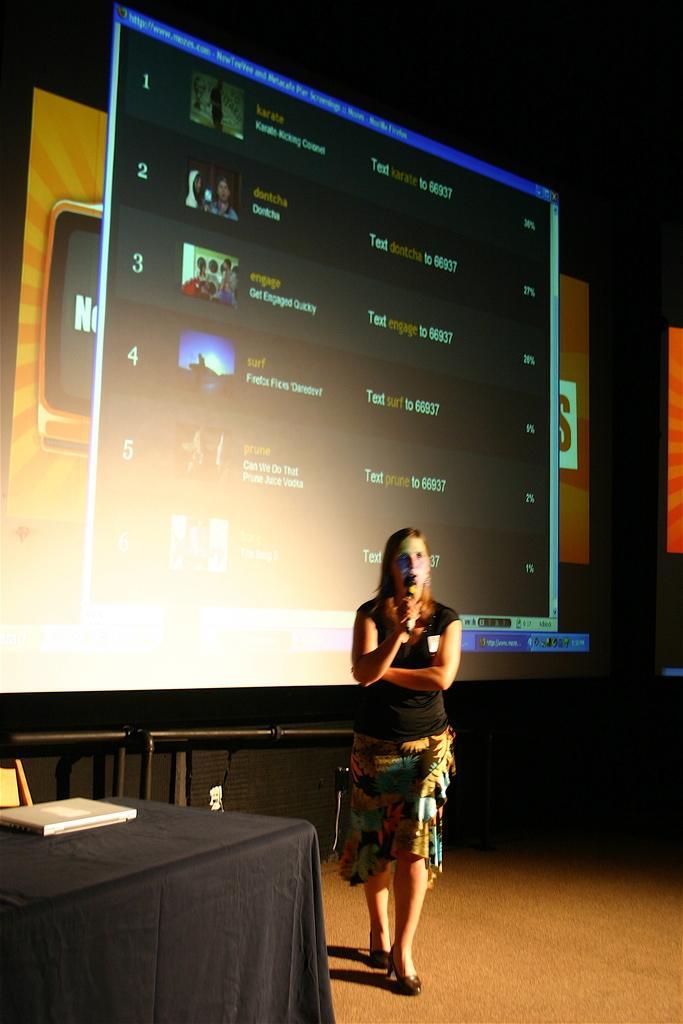In one or two sentences, can you explain what this image depicts? In this image there is a woman in the center holding a mic in her hand. On the left side there is a table which is covered with a black colour cloth and on the table there is a register. In the background there is a screen, on the screen there are some text visible. 